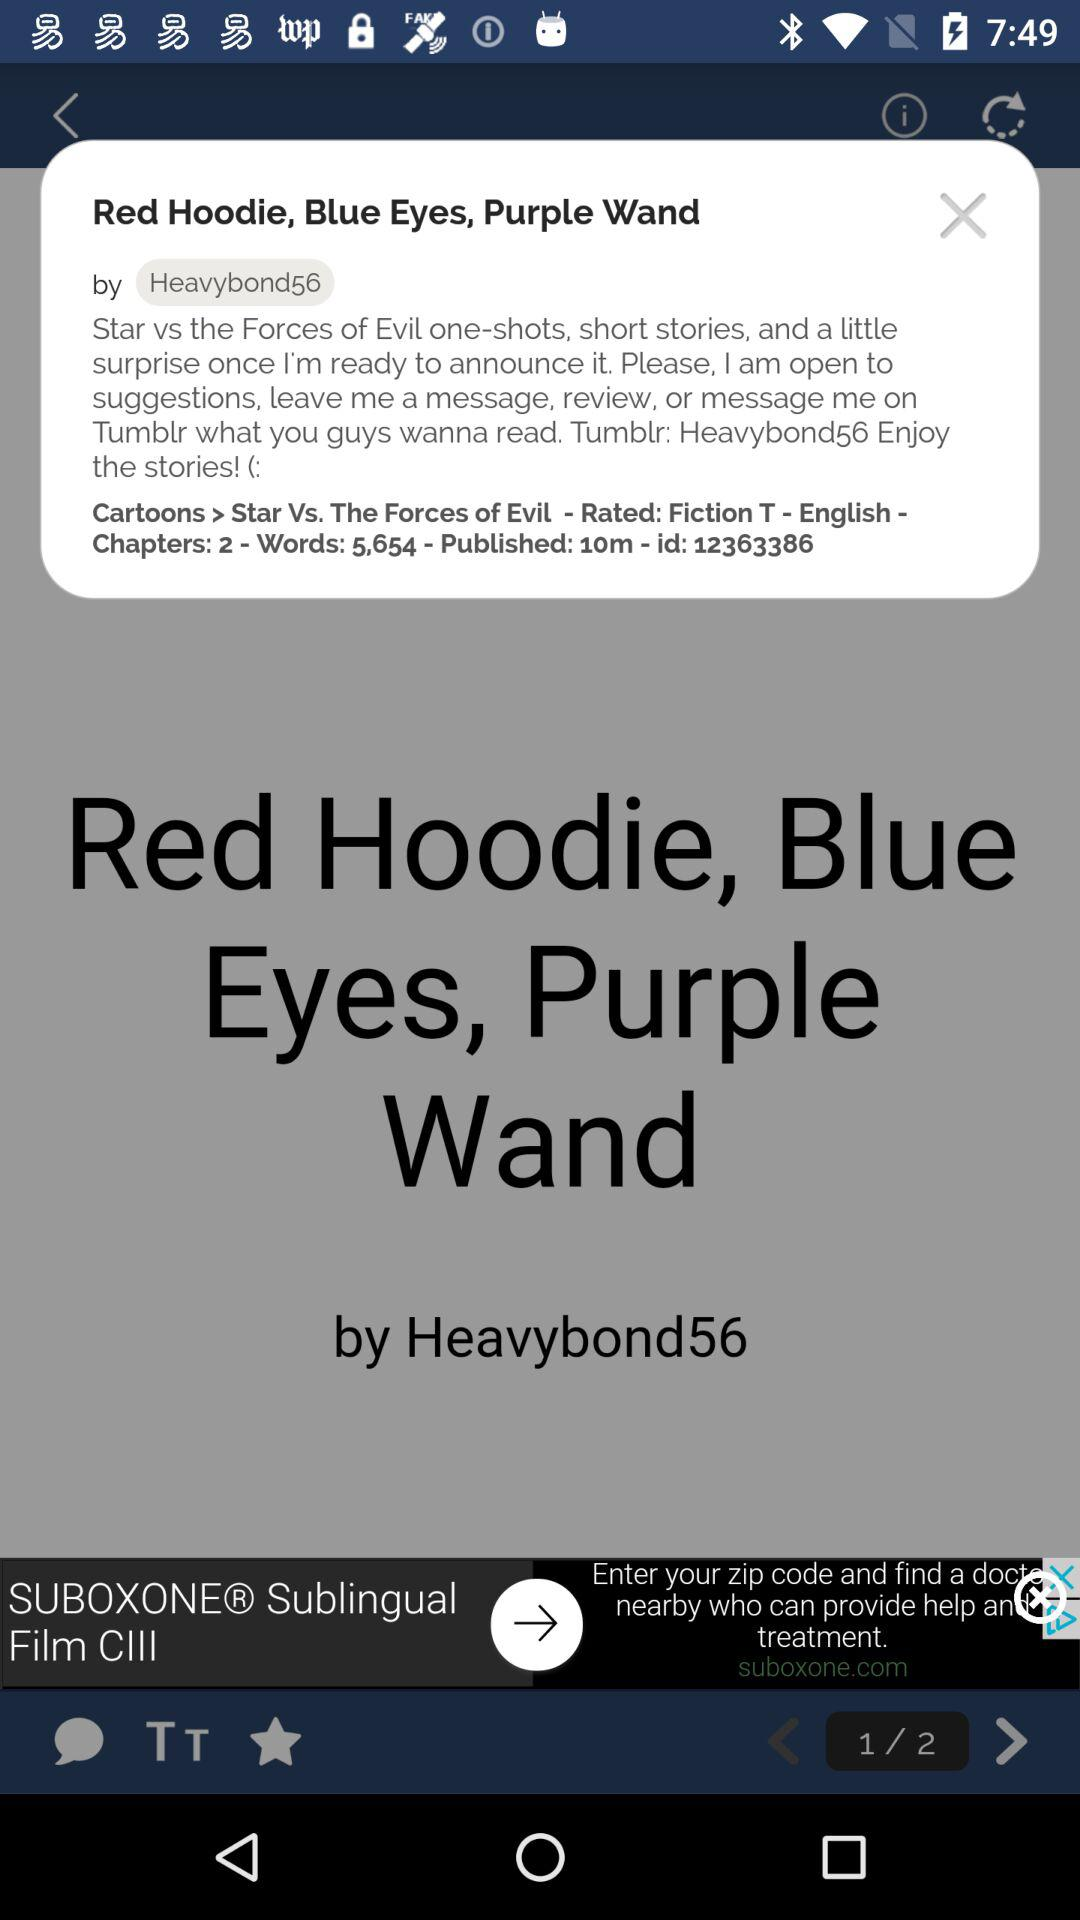How many chapters are there in the story?
Answer the question using a single word or phrase. 2 